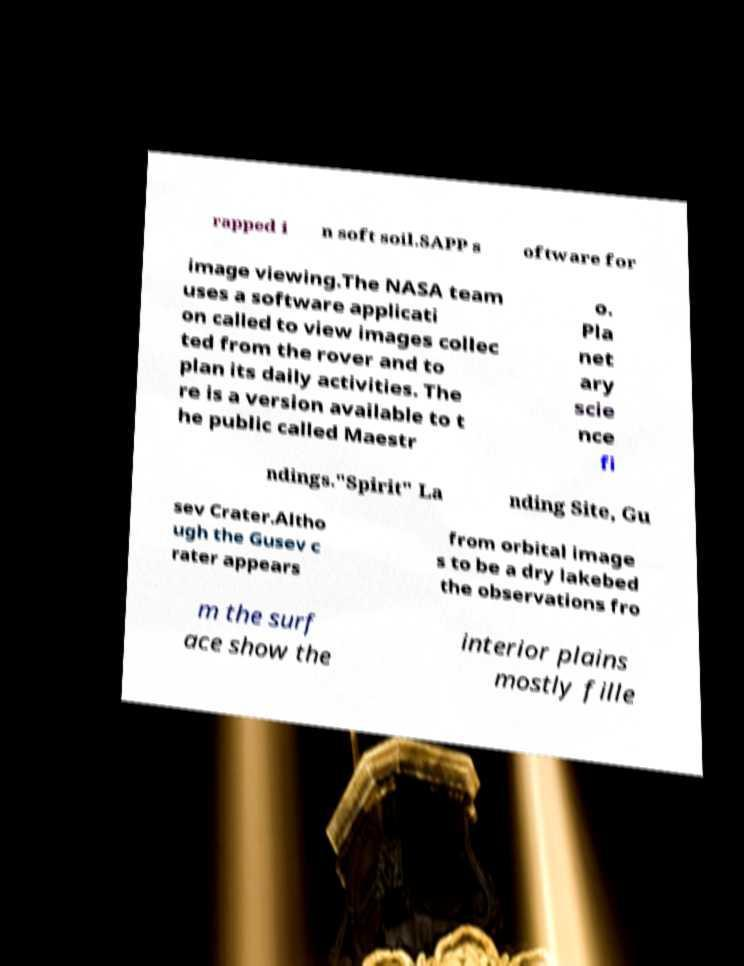Could you assist in decoding the text presented in this image and type it out clearly? rapped i n soft soil.SAPP s oftware for image viewing.The NASA team uses a software applicati on called to view images collec ted from the rover and to plan its daily activities. The re is a version available to t he public called Maestr o. Pla net ary scie nce fi ndings."Spirit" La nding Site, Gu sev Crater.Altho ugh the Gusev c rater appears from orbital image s to be a dry lakebed the observations fro m the surf ace show the interior plains mostly fille 